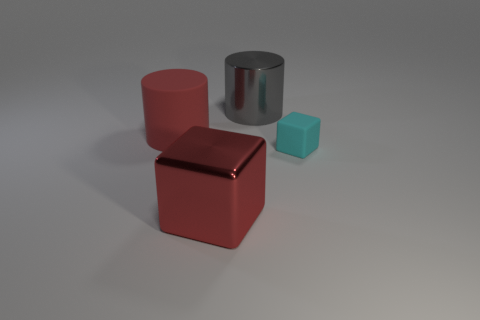What material is the other object that is the same shape as the small cyan object?
Offer a very short reply. Metal. Is the big red block made of the same material as the cyan block?
Your response must be concise. No. What color is the large metallic object left of the metal object that is behind the big red block?
Make the answer very short. Red. What is the size of the object that is the same material as the large cube?
Give a very brief answer. Large. How many cyan things are the same shape as the gray metal thing?
Make the answer very short. 0. What number of objects are either matte things in front of the matte cylinder or blocks that are to the right of the red metallic cube?
Your response must be concise. 1. There is a thing right of the metallic cylinder; how many small cyan blocks are to the left of it?
Make the answer very short. 0. Is the shape of the object left of the red metallic cube the same as the big metal object in front of the small block?
Make the answer very short. No. There is a thing that is the same color as the shiny cube; what shape is it?
Offer a very short reply. Cylinder. Is there a large thing made of the same material as the tiny cube?
Keep it short and to the point. Yes. 